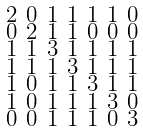<formula> <loc_0><loc_0><loc_500><loc_500>\begin{smallmatrix} 2 & 0 & 1 & 1 & 1 & 1 & 0 \\ 0 & 2 & 1 & 1 & 0 & 0 & 0 \\ 1 & 1 & 3 & 1 & 1 & 1 & 1 \\ 1 & 1 & 1 & 3 & 1 & 1 & 1 \\ 1 & 0 & 1 & 1 & 3 & 1 & 1 \\ 1 & 0 & 1 & 1 & 1 & 3 & 0 \\ 0 & 0 & 1 & 1 & 1 & 0 & 3 \end{smallmatrix}</formula> 